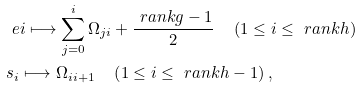<formula> <loc_0><loc_0><loc_500><loc_500>& \ e { i } \longmapsto \sum _ { j = 0 } ^ { i } \Omega _ { j i } + \frac { \ r a n k g - 1 } { 2 } \quad \left ( 1 \leq i \leq { \ r a n k h } \right ) \\ & s _ { i } \longmapsto \Omega _ { i i + 1 } \quad \left ( 1 \leq i \leq { \ r a n k h } - 1 \right ) ,</formula> 